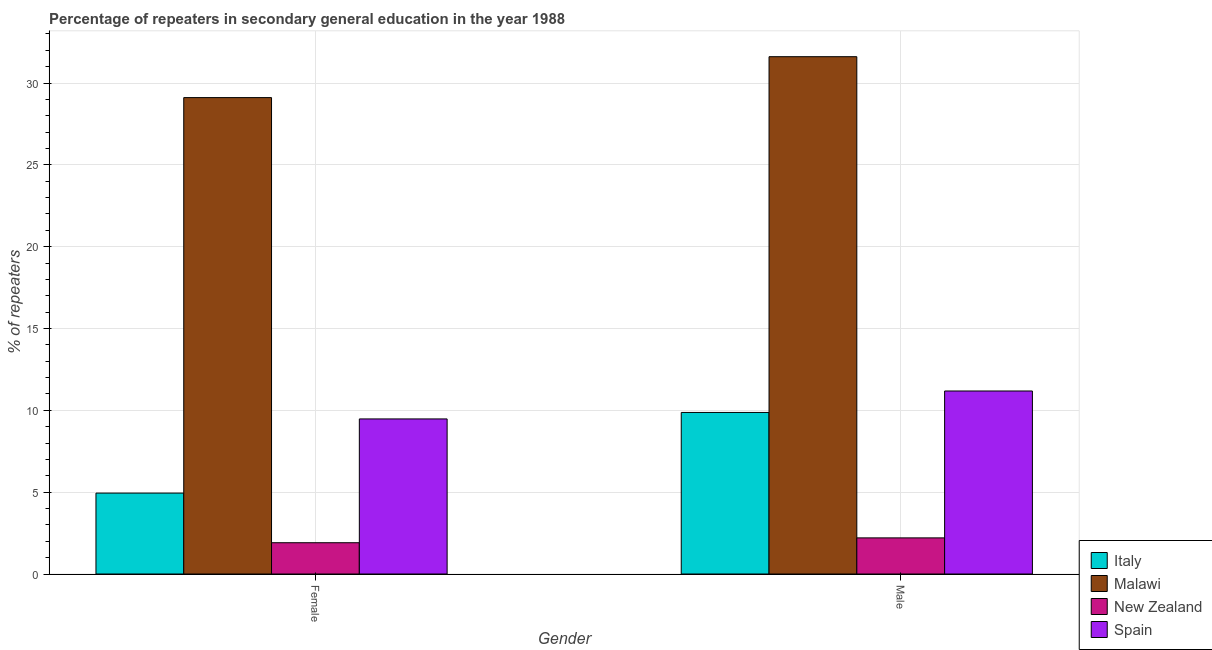How many different coloured bars are there?
Make the answer very short. 4. Are the number of bars per tick equal to the number of legend labels?
Keep it short and to the point. Yes. Are the number of bars on each tick of the X-axis equal?
Offer a terse response. Yes. What is the label of the 1st group of bars from the left?
Your answer should be very brief. Female. What is the percentage of male repeaters in Malawi?
Ensure brevity in your answer.  31.61. Across all countries, what is the maximum percentage of female repeaters?
Ensure brevity in your answer.  29.11. Across all countries, what is the minimum percentage of female repeaters?
Ensure brevity in your answer.  1.91. In which country was the percentage of female repeaters maximum?
Provide a succinct answer. Malawi. In which country was the percentage of female repeaters minimum?
Give a very brief answer. New Zealand. What is the total percentage of female repeaters in the graph?
Offer a very short reply. 45.44. What is the difference between the percentage of female repeaters in Malawi and that in Spain?
Keep it short and to the point. 19.63. What is the difference between the percentage of male repeaters in Italy and the percentage of female repeaters in Malawi?
Your answer should be compact. -19.24. What is the average percentage of female repeaters per country?
Your answer should be very brief. 11.36. What is the difference between the percentage of male repeaters and percentage of female repeaters in New Zealand?
Your answer should be compact. 0.3. What is the ratio of the percentage of female repeaters in New Zealand to that in Spain?
Your response must be concise. 0.2. Is the percentage of female repeaters in New Zealand less than that in Italy?
Keep it short and to the point. Yes. In how many countries, is the percentage of female repeaters greater than the average percentage of female repeaters taken over all countries?
Offer a very short reply. 1. What does the 3rd bar from the left in Female represents?
Offer a terse response. New Zealand. What does the 3rd bar from the right in Female represents?
Ensure brevity in your answer.  Malawi. Are all the bars in the graph horizontal?
Provide a succinct answer. No. How many countries are there in the graph?
Give a very brief answer. 4. What is the difference between two consecutive major ticks on the Y-axis?
Ensure brevity in your answer.  5. Are the values on the major ticks of Y-axis written in scientific E-notation?
Your answer should be very brief. No. Does the graph contain any zero values?
Your answer should be very brief. No. How many legend labels are there?
Keep it short and to the point. 4. What is the title of the graph?
Your answer should be very brief. Percentage of repeaters in secondary general education in the year 1988. Does "Namibia" appear as one of the legend labels in the graph?
Keep it short and to the point. No. What is the label or title of the Y-axis?
Ensure brevity in your answer.  % of repeaters. What is the % of repeaters of Italy in Female?
Provide a succinct answer. 4.94. What is the % of repeaters in Malawi in Female?
Your answer should be compact. 29.11. What is the % of repeaters of New Zealand in Female?
Provide a short and direct response. 1.91. What is the % of repeaters in Spain in Female?
Make the answer very short. 9.48. What is the % of repeaters in Italy in Male?
Offer a very short reply. 9.87. What is the % of repeaters of Malawi in Male?
Ensure brevity in your answer.  31.61. What is the % of repeaters in New Zealand in Male?
Your answer should be very brief. 2.21. What is the % of repeaters in Spain in Male?
Your answer should be compact. 11.18. Across all Gender, what is the maximum % of repeaters in Italy?
Make the answer very short. 9.87. Across all Gender, what is the maximum % of repeaters in Malawi?
Your answer should be compact. 31.61. Across all Gender, what is the maximum % of repeaters in New Zealand?
Offer a very short reply. 2.21. Across all Gender, what is the maximum % of repeaters in Spain?
Keep it short and to the point. 11.18. Across all Gender, what is the minimum % of repeaters in Italy?
Provide a succinct answer. 4.94. Across all Gender, what is the minimum % of repeaters of Malawi?
Ensure brevity in your answer.  29.11. Across all Gender, what is the minimum % of repeaters of New Zealand?
Your answer should be compact. 1.91. Across all Gender, what is the minimum % of repeaters in Spain?
Provide a short and direct response. 9.48. What is the total % of repeaters in Italy in the graph?
Keep it short and to the point. 14.82. What is the total % of repeaters of Malawi in the graph?
Keep it short and to the point. 60.72. What is the total % of repeaters in New Zealand in the graph?
Make the answer very short. 4.12. What is the total % of repeaters in Spain in the graph?
Give a very brief answer. 20.66. What is the difference between the % of repeaters of Italy in Female and that in Male?
Keep it short and to the point. -4.93. What is the difference between the % of repeaters in Malawi in Female and that in Male?
Make the answer very short. -2.5. What is the difference between the % of repeaters of New Zealand in Female and that in Male?
Offer a terse response. -0.3. What is the difference between the % of repeaters of Spain in Female and that in Male?
Give a very brief answer. -1.71. What is the difference between the % of repeaters of Italy in Female and the % of repeaters of Malawi in Male?
Offer a terse response. -26.66. What is the difference between the % of repeaters in Italy in Female and the % of repeaters in New Zealand in Male?
Provide a succinct answer. 2.74. What is the difference between the % of repeaters in Italy in Female and the % of repeaters in Spain in Male?
Offer a very short reply. -6.24. What is the difference between the % of repeaters of Malawi in Female and the % of repeaters of New Zealand in Male?
Offer a very short reply. 26.9. What is the difference between the % of repeaters in Malawi in Female and the % of repeaters in Spain in Male?
Ensure brevity in your answer.  17.93. What is the difference between the % of repeaters in New Zealand in Female and the % of repeaters in Spain in Male?
Your answer should be compact. -9.27. What is the average % of repeaters in Italy per Gender?
Keep it short and to the point. 7.41. What is the average % of repeaters of Malawi per Gender?
Ensure brevity in your answer.  30.36. What is the average % of repeaters in New Zealand per Gender?
Your answer should be compact. 2.06. What is the average % of repeaters of Spain per Gender?
Offer a terse response. 10.33. What is the difference between the % of repeaters in Italy and % of repeaters in Malawi in Female?
Ensure brevity in your answer.  -24.16. What is the difference between the % of repeaters of Italy and % of repeaters of New Zealand in Female?
Offer a terse response. 3.03. What is the difference between the % of repeaters of Italy and % of repeaters of Spain in Female?
Keep it short and to the point. -4.53. What is the difference between the % of repeaters of Malawi and % of repeaters of New Zealand in Female?
Ensure brevity in your answer.  27.2. What is the difference between the % of repeaters in Malawi and % of repeaters in Spain in Female?
Keep it short and to the point. 19.63. What is the difference between the % of repeaters in New Zealand and % of repeaters in Spain in Female?
Provide a short and direct response. -7.56. What is the difference between the % of repeaters of Italy and % of repeaters of Malawi in Male?
Your response must be concise. -21.74. What is the difference between the % of repeaters of Italy and % of repeaters of New Zealand in Male?
Provide a short and direct response. 7.66. What is the difference between the % of repeaters of Italy and % of repeaters of Spain in Male?
Provide a succinct answer. -1.31. What is the difference between the % of repeaters of Malawi and % of repeaters of New Zealand in Male?
Make the answer very short. 29.4. What is the difference between the % of repeaters in Malawi and % of repeaters in Spain in Male?
Keep it short and to the point. 20.43. What is the difference between the % of repeaters in New Zealand and % of repeaters in Spain in Male?
Ensure brevity in your answer.  -8.98. What is the ratio of the % of repeaters of Italy in Female to that in Male?
Ensure brevity in your answer.  0.5. What is the ratio of the % of repeaters in Malawi in Female to that in Male?
Ensure brevity in your answer.  0.92. What is the ratio of the % of repeaters in New Zealand in Female to that in Male?
Provide a succinct answer. 0.87. What is the ratio of the % of repeaters in Spain in Female to that in Male?
Keep it short and to the point. 0.85. What is the difference between the highest and the second highest % of repeaters of Italy?
Provide a succinct answer. 4.93. What is the difference between the highest and the second highest % of repeaters in Malawi?
Offer a terse response. 2.5. What is the difference between the highest and the second highest % of repeaters of New Zealand?
Your response must be concise. 0.3. What is the difference between the highest and the second highest % of repeaters in Spain?
Provide a succinct answer. 1.71. What is the difference between the highest and the lowest % of repeaters in Italy?
Ensure brevity in your answer.  4.93. What is the difference between the highest and the lowest % of repeaters in Malawi?
Ensure brevity in your answer.  2.5. What is the difference between the highest and the lowest % of repeaters of New Zealand?
Your response must be concise. 0.3. What is the difference between the highest and the lowest % of repeaters of Spain?
Offer a very short reply. 1.71. 